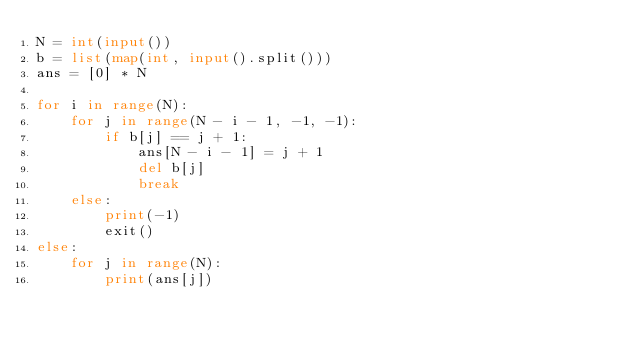Convert code to text. <code><loc_0><loc_0><loc_500><loc_500><_Python_>N = int(input())
b = list(map(int, input().split()))
ans = [0] * N

for i in range(N):
    for j in range(N - i - 1, -1, -1):
        if b[j] == j + 1:
            ans[N - i - 1] = j + 1
            del b[j]
            break
    else:
        print(-1)
        exit()
else:
    for j in range(N):
        print(ans[j])
</code> 